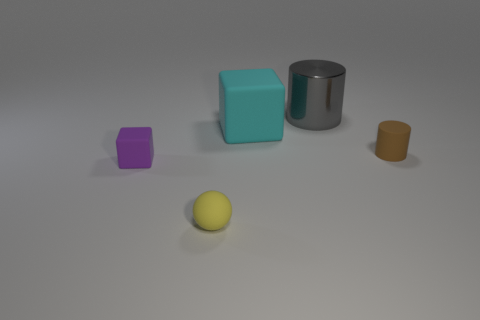Is the size of the purple matte block the same as the cyan cube that is behind the yellow matte sphere?
Your response must be concise. No. How many blocks are either large gray metallic things or tiny purple objects?
Provide a succinct answer. 1. What is the size of the cylinder that is made of the same material as the cyan object?
Ensure brevity in your answer.  Small. Do the cylinder behind the brown object and the matte cube that is to the right of the small matte ball have the same size?
Your answer should be very brief. Yes. What number of things are either cyan rubber blocks or tiny purple cubes?
Give a very brief answer. 2. The tiny purple thing is what shape?
Your answer should be very brief. Cube. There is a rubber thing that is the same shape as the large metallic object; what is its size?
Provide a succinct answer. Small. Are there any other things that are made of the same material as the gray thing?
Make the answer very short. No. What size is the matte cube that is on the right side of the object left of the small sphere?
Offer a very short reply. Large. Are there an equal number of yellow spheres behind the purple rubber block and large matte things?
Your answer should be compact. No. 